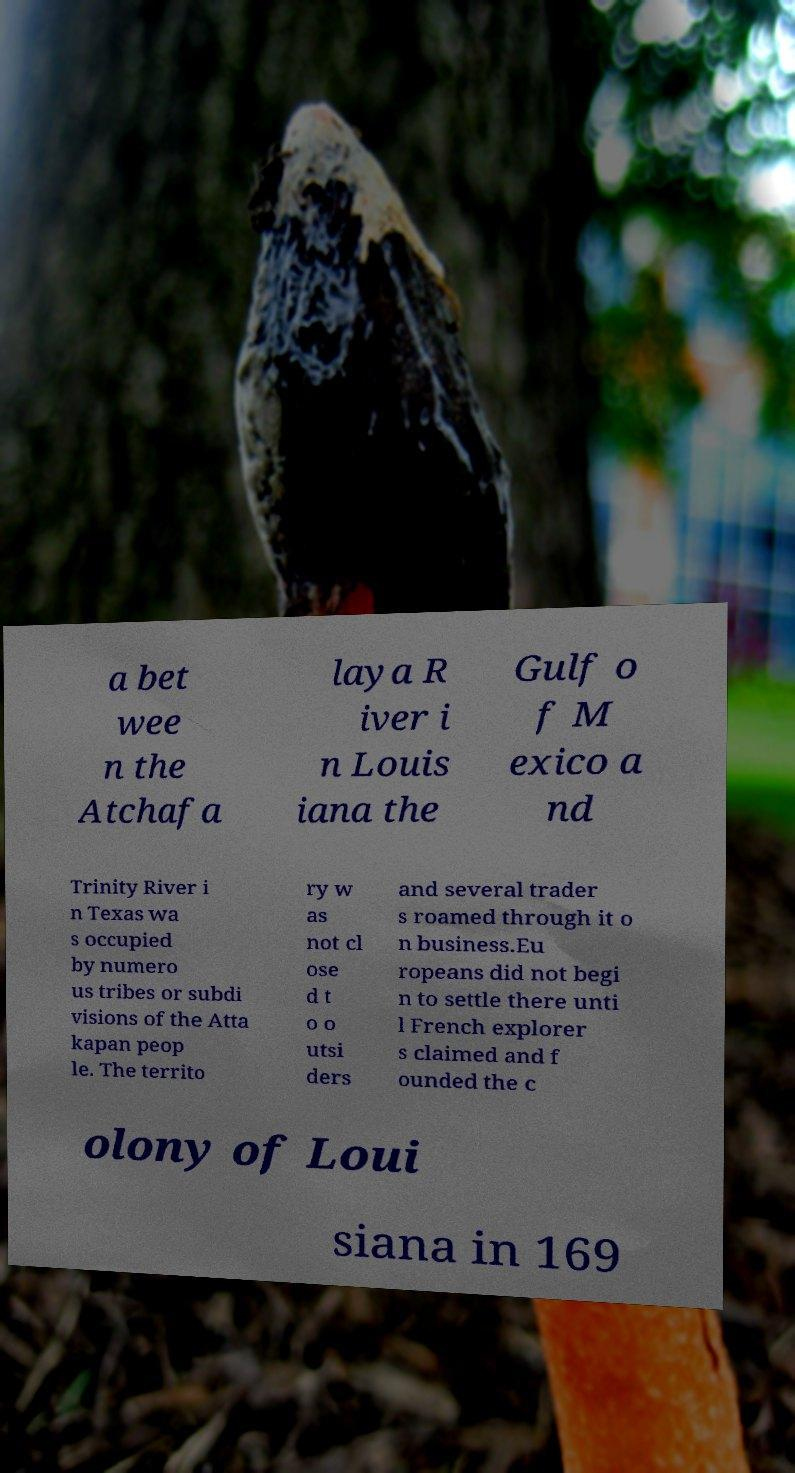Please identify and transcribe the text found in this image. a bet wee n the Atchafa laya R iver i n Louis iana the Gulf o f M exico a nd Trinity River i n Texas wa s occupied by numero us tribes or subdi visions of the Atta kapan peop le. The territo ry w as not cl ose d t o o utsi ders and several trader s roamed through it o n business.Eu ropeans did not begi n to settle there unti l French explorer s claimed and f ounded the c olony of Loui siana in 169 